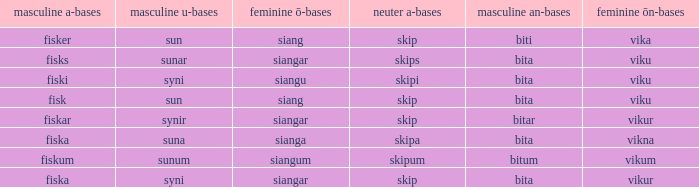What is the masculine an form for the word with a feminine ö ending of siangar and a masculine u ending of sunar? Bita. 